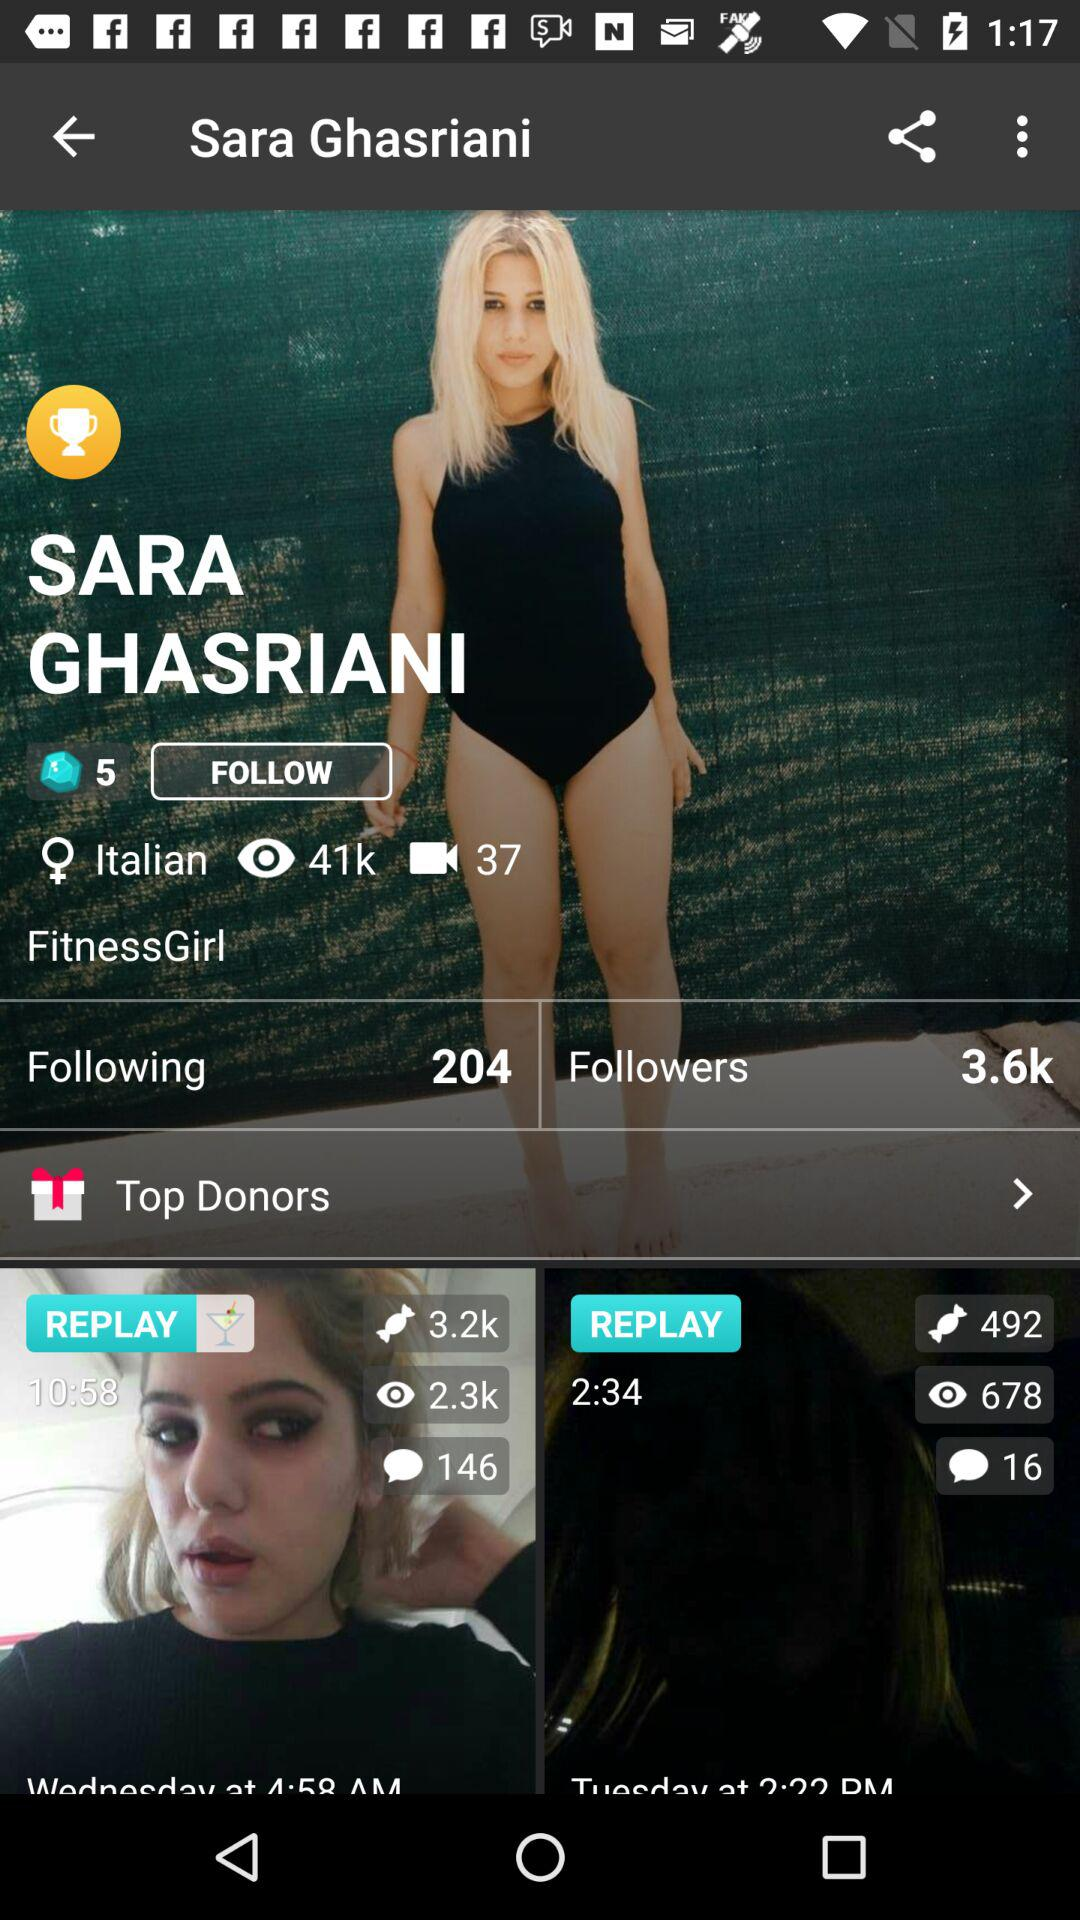What is the country name?
When the provided information is insufficient, respond with <no answer>. <no answer> 